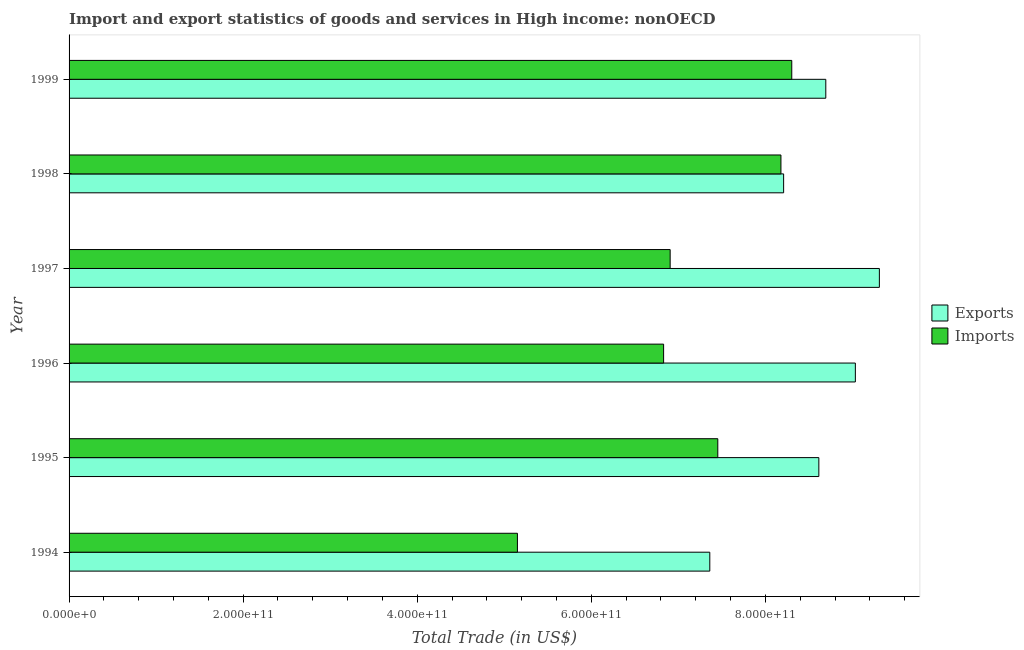How many different coloured bars are there?
Give a very brief answer. 2. How many groups of bars are there?
Provide a short and direct response. 6. How many bars are there on the 2nd tick from the top?
Make the answer very short. 2. What is the label of the 5th group of bars from the top?
Your response must be concise. 1995. What is the export of goods and services in 1997?
Make the answer very short. 9.31e+11. Across all years, what is the maximum export of goods and services?
Your answer should be very brief. 9.31e+11. Across all years, what is the minimum imports of goods and services?
Offer a very short reply. 5.15e+11. In which year was the export of goods and services maximum?
Ensure brevity in your answer.  1997. What is the total imports of goods and services in the graph?
Your answer should be very brief. 4.28e+12. What is the difference between the imports of goods and services in 1994 and that in 1999?
Your response must be concise. -3.15e+11. What is the difference between the imports of goods and services in 1996 and the export of goods and services in 1995?
Offer a terse response. -1.78e+11. What is the average export of goods and services per year?
Keep it short and to the point. 8.54e+11. In the year 1997, what is the difference between the imports of goods and services and export of goods and services?
Your answer should be very brief. -2.40e+11. In how many years, is the imports of goods and services greater than 680000000000 US$?
Your response must be concise. 5. What is the ratio of the export of goods and services in 1997 to that in 1999?
Your answer should be very brief. 1.07. Is the difference between the imports of goods and services in 1995 and 1996 greater than the difference between the export of goods and services in 1995 and 1996?
Your response must be concise. Yes. What is the difference between the highest and the second highest export of goods and services?
Provide a succinct answer. 2.76e+1. What is the difference between the highest and the lowest imports of goods and services?
Offer a terse response. 3.15e+11. In how many years, is the imports of goods and services greater than the average imports of goods and services taken over all years?
Provide a short and direct response. 3. Is the sum of the export of goods and services in 1998 and 1999 greater than the maximum imports of goods and services across all years?
Your answer should be compact. Yes. What does the 1st bar from the top in 1994 represents?
Your answer should be compact. Imports. What does the 1st bar from the bottom in 1997 represents?
Provide a succinct answer. Exports. How many bars are there?
Keep it short and to the point. 12. Are all the bars in the graph horizontal?
Your answer should be very brief. Yes. How many years are there in the graph?
Offer a terse response. 6. What is the difference between two consecutive major ticks on the X-axis?
Your answer should be very brief. 2.00e+11. Are the values on the major ticks of X-axis written in scientific E-notation?
Your answer should be very brief. Yes. Does the graph contain any zero values?
Offer a very short reply. No. How many legend labels are there?
Provide a short and direct response. 2. How are the legend labels stacked?
Ensure brevity in your answer.  Vertical. What is the title of the graph?
Give a very brief answer. Import and export statistics of goods and services in High income: nonOECD. What is the label or title of the X-axis?
Offer a very short reply. Total Trade (in US$). What is the label or title of the Y-axis?
Provide a short and direct response. Year. What is the Total Trade (in US$) in Exports in 1994?
Offer a very short reply. 7.36e+11. What is the Total Trade (in US$) in Imports in 1994?
Your answer should be very brief. 5.15e+11. What is the Total Trade (in US$) in Exports in 1995?
Offer a terse response. 8.61e+11. What is the Total Trade (in US$) in Imports in 1995?
Offer a very short reply. 7.45e+11. What is the Total Trade (in US$) of Exports in 1996?
Offer a terse response. 9.03e+11. What is the Total Trade (in US$) of Imports in 1996?
Give a very brief answer. 6.83e+11. What is the Total Trade (in US$) of Exports in 1997?
Offer a very short reply. 9.31e+11. What is the Total Trade (in US$) in Imports in 1997?
Keep it short and to the point. 6.91e+11. What is the Total Trade (in US$) in Exports in 1998?
Give a very brief answer. 8.21e+11. What is the Total Trade (in US$) in Imports in 1998?
Your response must be concise. 8.18e+11. What is the Total Trade (in US$) of Exports in 1999?
Your answer should be compact. 8.69e+11. What is the Total Trade (in US$) in Imports in 1999?
Your response must be concise. 8.30e+11. Across all years, what is the maximum Total Trade (in US$) of Exports?
Provide a succinct answer. 9.31e+11. Across all years, what is the maximum Total Trade (in US$) of Imports?
Your answer should be very brief. 8.30e+11. Across all years, what is the minimum Total Trade (in US$) of Exports?
Provide a short and direct response. 7.36e+11. Across all years, what is the minimum Total Trade (in US$) in Imports?
Provide a succinct answer. 5.15e+11. What is the total Total Trade (in US$) of Exports in the graph?
Give a very brief answer. 5.12e+12. What is the total Total Trade (in US$) of Imports in the graph?
Ensure brevity in your answer.  4.28e+12. What is the difference between the Total Trade (in US$) in Exports in 1994 and that in 1995?
Offer a terse response. -1.25e+11. What is the difference between the Total Trade (in US$) in Imports in 1994 and that in 1995?
Your answer should be very brief. -2.30e+11. What is the difference between the Total Trade (in US$) of Exports in 1994 and that in 1996?
Offer a very short reply. -1.67e+11. What is the difference between the Total Trade (in US$) of Imports in 1994 and that in 1996?
Your answer should be compact. -1.68e+11. What is the difference between the Total Trade (in US$) of Exports in 1994 and that in 1997?
Make the answer very short. -1.95e+11. What is the difference between the Total Trade (in US$) of Imports in 1994 and that in 1997?
Provide a short and direct response. -1.75e+11. What is the difference between the Total Trade (in US$) in Exports in 1994 and that in 1998?
Your response must be concise. -8.48e+1. What is the difference between the Total Trade (in US$) in Imports in 1994 and that in 1998?
Make the answer very short. -3.03e+11. What is the difference between the Total Trade (in US$) in Exports in 1994 and that in 1999?
Provide a succinct answer. -1.33e+11. What is the difference between the Total Trade (in US$) of Imports in 1994 and that in 1999?
Provide a succinct answer. -3.15e+11. What is the difference between the Total Trade (in US$) of Exports in 1995 and that in 1996?
Keep it short and to the point. -4.20e+1. What is the difference between the Total Trade (in US$) in Imports in 1995 and that in 1996?
Your response must be concise. 6.23e+1. What is the difference between the Total Trade (in US$) of Exports in 1995 and that in 1997?
Your response must be concise. -6.95e+1. What is the difference between the Total Trade (in US$) in Imports in 1995 and that in 1997?
Your answer should be compact. 5.47e+1. What is the difference between the Total Trade (in US$) of Exports in 1995 and that in 1998?
Your answer should be compact. 4.05e+1. What is the difference between the Total Trade (in US$) in Imports in 1995 and that in 1998?
Offer a terse response. -7.25e+1. What is the difference between the Total Trade (in US$) of Exports in 1995 and that in 1999?
Keep it short and to the point. -7.98e+09. What is the difference between the Total Trade (in US$) in Imports in 1995 and that in 1999?
Provide a short and direct response. -8.50e+1. What is the difference between the Total Trade (in US$) in Exports in 1996 and that in 1997?
Keep it short and to the point. -2.76e+1. What is the difference between the Total Trade (in US$) of Imports in 1996 and that in 1997?
Make the answer very short. -7.51e+09. What is the difference between the Total Trade (in US$) of Exports in 1996 and that in 1998?
Your answer should be very brief. 8.24e+1. What is the difference between the Total Trade (in US$) of Imports in 1996 and that in 1998?
Ensure brevity in your answer.  -1.35e+11. What is the difference between the Total Trade (in US$) in Exports in 1996 and that in 1999?
Ensure brevity in your answer.  3.40e+1. What is the difference between the Total Trade (in US$) in Imports in 1996 and that in 1999?
Provide a short and direct response. -1.47e+11. What is the difference between the Total Trade (in US$) of Exports in 1997 and that in 1998?
Give a very brief answer. 1.10e+11. What is the difference between the Total Trade (in US$) in Imports in 1997 and that in 1998?
Ensure brevity in your answer.  -1.27e+11. What is the difference between the Total Trade (in US$) of Exports in 1997 and that in 1999?
Give a very brief answer. 6.16e+1. What is the difference between the Total Trade (in US$) in Imports in 1997 and that in 1999?
Ensure brevity in your answer.  -1.40e+11. What is the difference between the Total Trade (in US$) in Exports in 1998 and that in 1999?
Make the answer very short. -4.84e+1. What is the difference between the Total Trade (in US$) in Imports in 1998 and that in 1999?
Ensure brevity in your answer.  -1.24e+1. What is the difference between the Total Trade (in US$) of Exports in 1994 and the Total Trade (in US$) of Imports in 1995?
Offer a very short reply. -9.20e+09. What is the difference between the Total Trade (in US$) in Exports in 1994 and the Total Trade (in US$) in Imports in 1996?
Provide a succinct answer. 5.31e+1. What is the difference between the Total Trade (in US$) of Exports in 1994 and the Total Trade (in US$) of Imports in 1997?
Provide a succinct answer. 4.55e+1. What is the difference between the Total Trade (in US$) of Exports in 1994 and the Total Trade (in US$) of Imports in 1998?
Ensure brevity in your answer.  -8.17e+1. What is the difference between the Total Trade (in US$) of Exports in 1994 and the Total Trade (in US$) of Imports in 1999?
Offer a very short reply. -9.42e+1. What is the difference between the Total Trade (in US$) in Exports in 1995 and the Total Trade (in US$) in Imports in 1996?
Offer a very short reply. 1.78e+11. What is the difference between the Total Trade (in US$) in Exports in 1995 and the Total Trade (in US$) in Imports in 1997?
Your response must be concise. 1.71e+11. What is the difference between the Total Trade (in US$) in Exports in 1995 and the Total Trade (in US$) in Imports in 1998?
Offer a very short reply. 4.36e+1. What is the difference between the Total Trade (in US$) in Exports in 1995 and the Total Trade (in US$) in Imports in 1999?
Your response must be concise. 3.11e+1. What is the difference between the Total Trade (in US$) in Exports in 1996 and the Total Trade (in US$) in Imports in 1997?
Provide a succinct answer. 2.13e+11. What is the difference between the Total Trade (in US$) in Exports in 1996 and the Total Trade (in US$) in Imports in 1998?
Your response must be concise. 8.55e+1. What is the difference between the Total Trade (in US$) of Exports in 1996 and the Total Trade (in US$) of Imports in 1999?
Offer a very short reply. 7.31e+1. What is the difference between the Total Trade (in US$) in Exports in 1997 and the Total Trade (in US$) in Imports in 1998?
Give a very brief answer. 1.13e+11. What is the difference between the Total Trade (in US$) of Exports in 1997 and the Total Trade (in US$) of Imports in 1999?
Keep it short and to the point. 1.01e+11. What is the difference between the Total Trade (in US$) in Exports in 1998 and the Total Trade (in US$) in Imports in 1999?
Make the answer very short. -9.34e+09. What is the average Total Trade (in US$) of Exports per year?
Make the answer very short. 8.54e+11. What is the average Total Trade (in US$) in Imports per year?
Provide a short and direct response. 7.14e+11. In the year 1994, what is the difference between the Total Trade (in US$) in Exports and Total Trade (in US$) in Imports?
Your answer should be compact. 2.21e+11. In the year 1995, what is the difference between the Total Trade (in US$) of Exports and Total Trade (in US$) of Imports?
Make the answer very short. 1.16e+11. In the year 1996, what is the difference between the Total Trade (in US$) in Exports and Total Trade (in US$) in Imports?
Offer a very short reply. 2.20e+11. In the year 1997, what is the difference between the Total Trade (in US$) of Exports and Total Trade (in US$) of Imports?
Your response must be concise. 2.40e+11. In the year 1998, what is the difference between the Total Trade (in US$) in Exports and Total Trade (in US$) in Imports?
Your answer should be very brief. 3.10e+09. In the year 1999, what is the difference between the Total Trade (in US$) of Exports and Total Trade (in US$) of Imports?
Provide a short and direct response. 3.91e+1. What is the ratio of the Total Trade (in US$) of Exports in 1994 to that in 1995?
Give a very brief answer. 0.85. What is the ratio of the Total Trade (in US$) of Imports in 1994 to that in 1995?
Your answer should be very brief. 0.69. What is the ratio of the Total Trade (in US$) of Exports in 1994 to that in 1996?
Your answer should be compact. 0.81. What is the ratio of the Total Trade (in US$) of Imports in 1994 to that in 1996?
Offer a terse response. 0.75. What is the ratio of the Total Trade (in US$) in Exports in 1994 to that in 1997?
Give a very brief answer. 0.79. What is the ratio of the Total Trade (in US$) in Imports in 1994 to that in 1997?
Offer a very short reply. 0.75. What is the ratio of the Total Trade (in US$) in Exports in 1994 to that in 1998?
Your answer should be compact. 0.9. What is the ratio of the Total Trade (in US$) in Imports in 1994 to that in 1998?
Keep it short and to the point. 0.63. What is the ratio of the Total Trade (in US$) in Exports in 1994 to that in 1999?
Offer a very short reply. 0.85. What is the ratio of the Total Trade (in US$) in Imports in 1994 to that in 1999?
Ensure brevity in your answer.  0.62. What is the ratio of the Total Trade (in US$) of Exports in 1995 to that in 1996?
Provide a succinct answer. 0.95. What is the ratio of the Total Trade (in US$) in Imports in 1995 to that in 1996?
Your answer should be very brief. 1.09. What is the ratio of the Total Trade (in US$) in Exports in 1995 to that in 1997?
Give a very brief answer. 0.93. What is the ratio of the Total Trade (in US$) of Imports in 1995 to that in 1997?
Your response must be concise. 1.08. What is the ratio of the Total Trade (in US$) of Exports in 1995 to that in 1998?
Offer a terse response. 1.05. What is the ratio of the Total Trade (in US$) in Imports in 1995 to that in 1998?
Your response must be concise. 0.91. What is the ratio of the Total Trade (in US$) in Imports in 1995 to that in 1999?
Offer a very short reply. 0.9. What is the ratio of the Total Trade (in US$) of Exports in 1996 to that in 1997?
Your answer should be very brief. 0.97. What is the ratio of the Total Trade (in US$) of Exports in 1996 to that in 1998?
Provide a short and direct response. 1.1. What is the ratio of the Total Trade (in US$) in Imports in 1996 to that in 1998?
Your response must be concise. 0.84. What is the ratio of the Total Trade (in US$) of Exports in 1996 to that in 1999?
Ensure brevity in your answer.  1.04. What is the ratio of the Total Trade (in US$) of Imports in 1996 to that in 1999?
Keep it short and to the point. 0.82. What is the ratio of the Total Trade (in US$) of Exports in 1997 to that in 1998?
Your answer should be very brief. 1.13. What is the ratio of the Total Trade (in US$) of Imports in 1997 to that in 1998?
Give a very brief answer. 0.84. What is the ratio of the Total Trade (in US$) of Exports in 1997 to that in 1999?
Your response must be concise. 1.07. What is the ratio of the Total Trade (in US$) of Imports in 1997 to that in 1999?
Make the answer very short. 0.83. What is the ratio of the Total Trade (in US$) in Exports in 1998 to that in 1999?
Make the answer very short. 0.94. What is the ratio of the Total Trade (in US$) in Imports in 1998 to that in 1999?
Your answer should be compact. 0.98. What is the difference between the highest and the second highest Total Trade (in US$) in Exports?
Provide a succinct answer. 2.76e+1. What is the difference between the highest and the second highest Total Trade (in US$) of Imports?
Provide a short and direct response. 1.24e+1. What is the difference between the highest and the lowest Total Trade (in US$) in Exports?
Your answer should be very brief. 1.95e+11. What is the difference between the highest and the lowest Total Trade (in US$) in Imports?
Your answer should be very brief. 3.15e+11. 